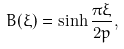<formula> <loc_0><loc_0><loc_500><loc_500>B ( \xi ) = \sinh \frac { \pi \xi } { 2 p } ,</formula> 